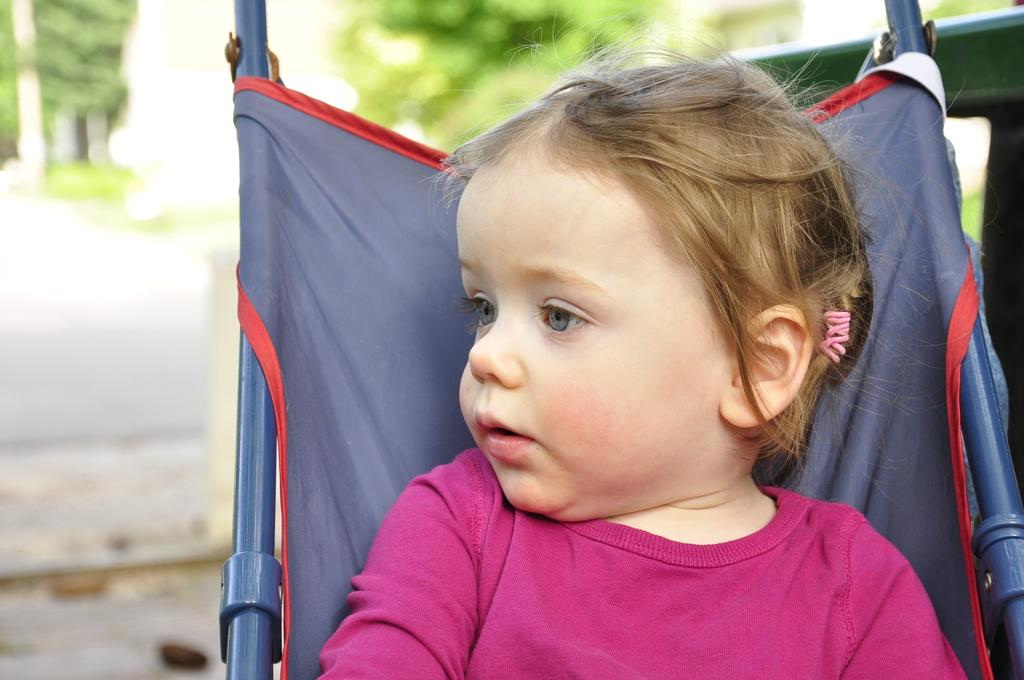What is the main subject of the image? The main subject of the image is a kid. What is the kid doing in the image? The kid is sitting on an object. Where is the object located in the image? The object is on the right side of the image. What can be seen in the background of the image? There is a tree in the image. Where is the tree located in the image? The tree is at the top of the image. What type of range can be seen in the image? There is no range present in the image. How many clovers are visible on the object the kid is sitting on? There is no mention of clovers in the image, and the object the kid is sitting on is not described in detail. 